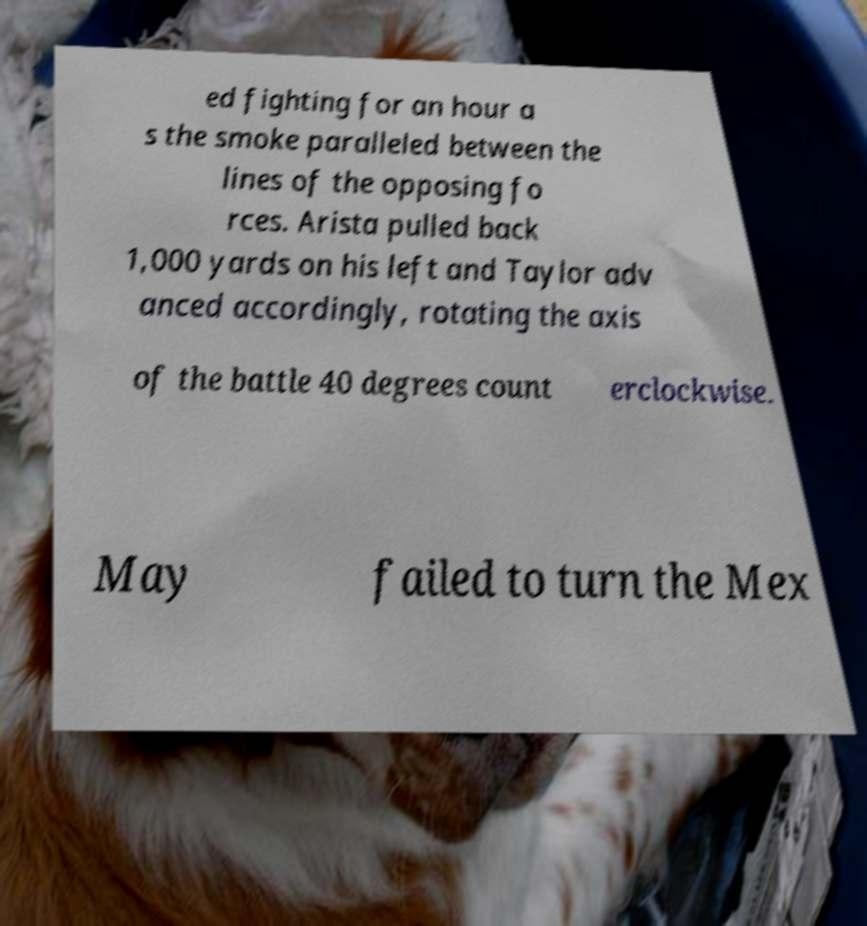Please identify and transcribe the text found in this image. ed fighting for an hour a s the smoke paralleled between the lines of the opposing fo rces. Arista pulled back 1,000 yards on his left and Taylor adv anced accordingly, rotating the axis of the battle 40 degrees count erclockwise. May failed to turn the Mex 